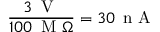Convert formula to latex. <formula><loc_0><loc_0><loc_500><loc_500>\frac { 3 \, V } { 1 0 0 \, M \Omega } = 3 0 \, n A</formula> 